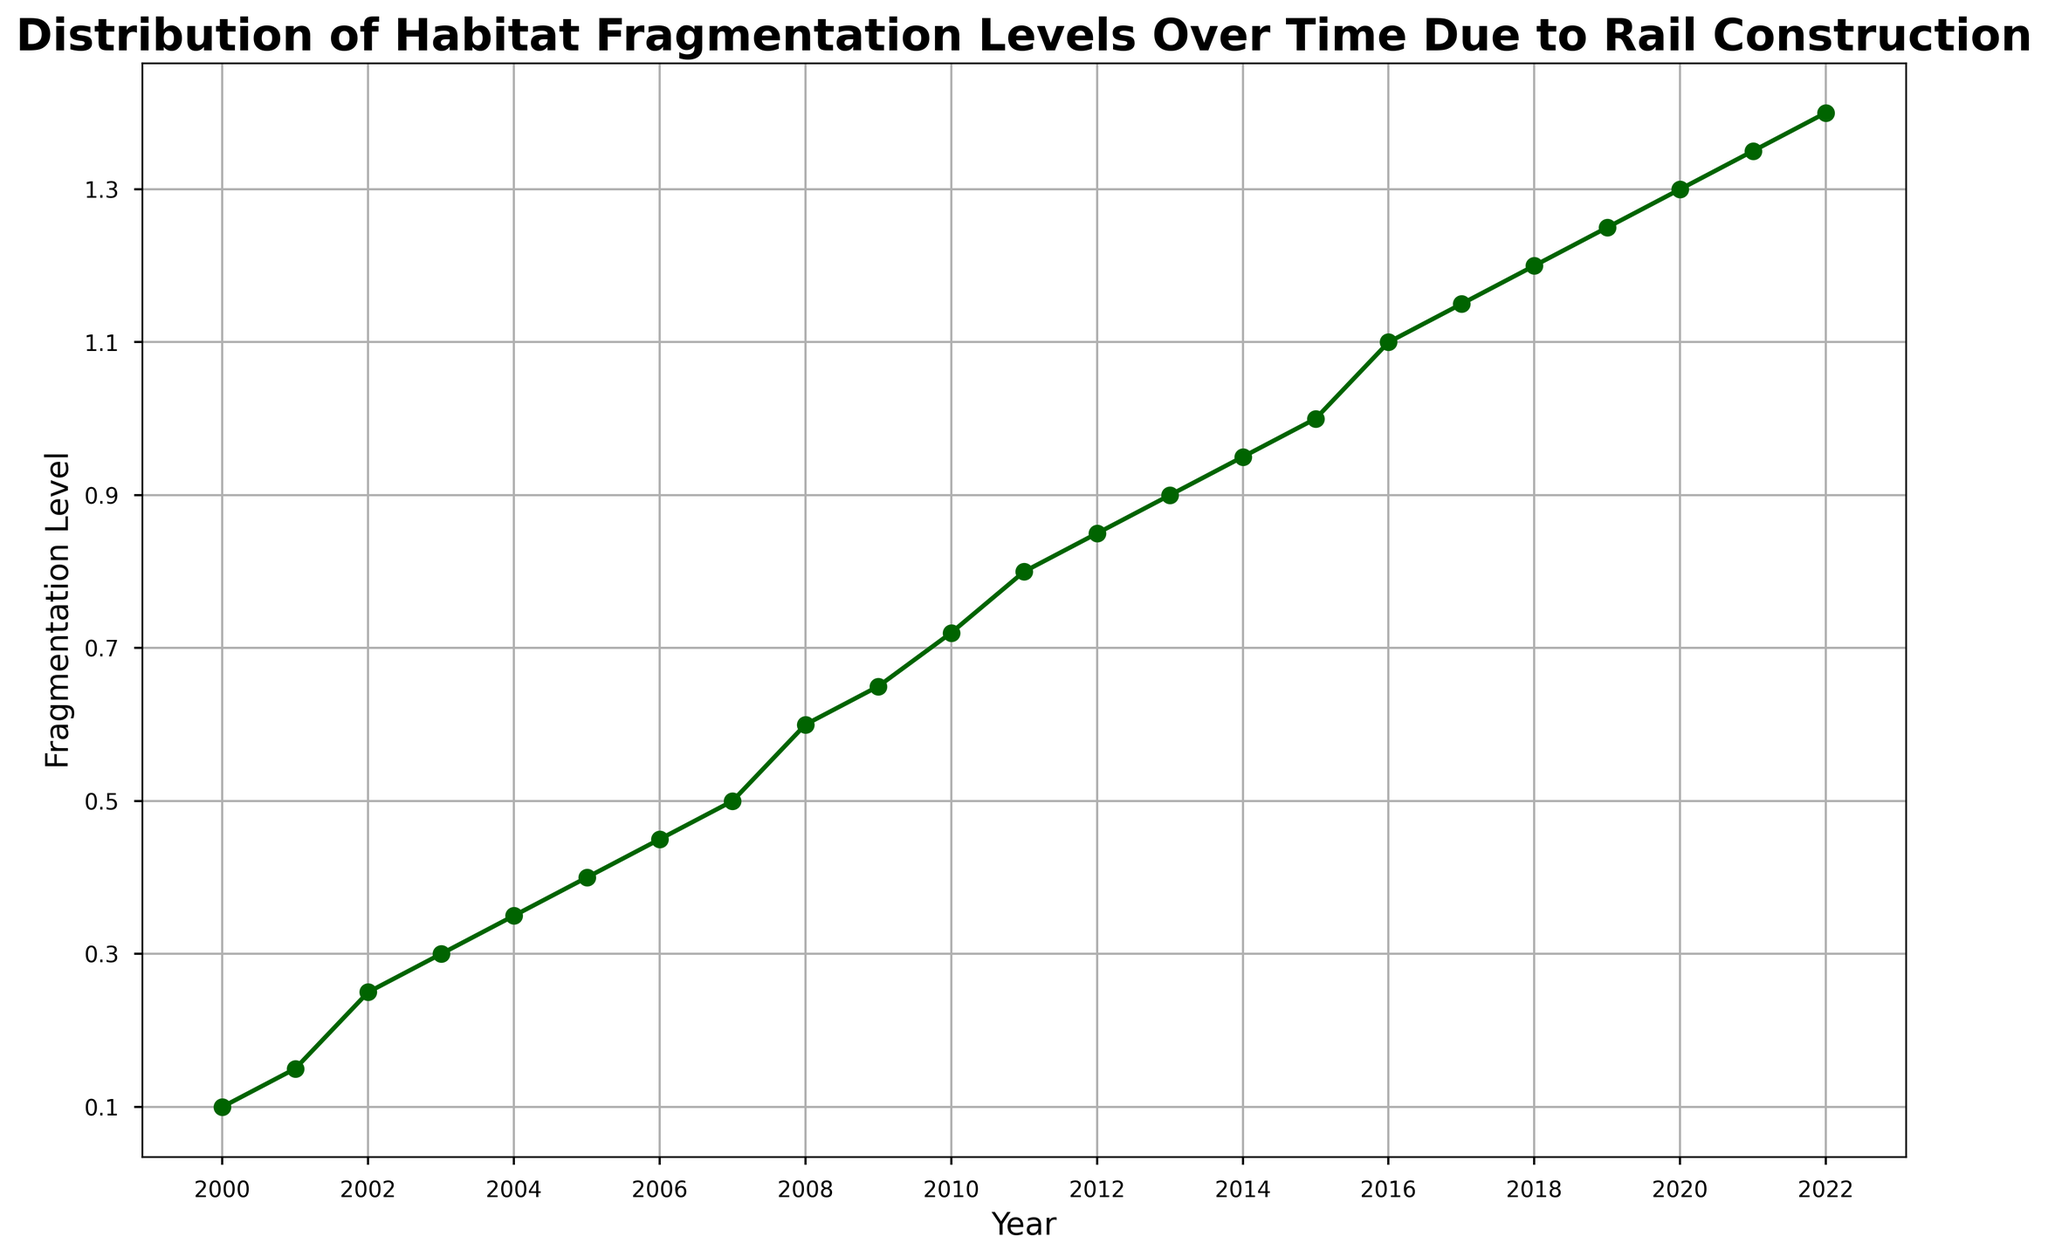What is the fragmentation level in 2005? Look at the point marked for the year 2005 on the x-axis and read the corresponding fragmentation level on the y-axis. The point is at the level 0.4.
Answer: 0.4 Between which two consecutive years did the fragmentation level increase the most? Calculate the differences between fragmentation levels for all consecutive years and identify the two years with the highest increase. The highest increase is from 2010 to 2011, from 0.72 to 0.8.
Answer: 2010 and 2011 What is the average fragmentation level from 2000 to 2005? Sum the fragmentation levels from 2000, 2001, 2002, 2003, 2004, and 2005, then divide by the number of years (6). The sum is 0.1 + 0.15 + 0.25 + 0.3 + 0.35 + 0.4, which equals 1.55. The average is 1.55 / 6.
Answer: 0.258 Which year shows a fragmentation level of 0.95? Find the year on the x-axis that corresponds to the fragmentation level of 0.95 on the y-axis. The plot shows the year is 2014.
Answer: 2014 By how much did the fragmentation level change from 2000 to 2022? Subtract the fragmentation level in 2000 from the fragmentation level in 2022. The level in 2022 is 1.4, and in 2000 it is 0.1. The change is 1.4 - 0.1.
Answer: 1.3 What is the trend observed in the fragmentation levels over the years? Observe the general direction of the plot line from left to right. The fragmentation levels steadily increase over the years.
Answer: Increasing Which year experienced the first fragmentation level above 1.0? Find the first year on the x-axis where the fragmentation level on the y-axis exceeds 1.0. The year appears to be 2016.
Answer: 2016 How many years did it take for the fragmentation level to double from its 2004 level? Determine the fragmentation level in 2004, which is 0.35, double that value to get 0.7, and find the year when the fragmentation level first reaches or exceeds 0.7. The year is 2010, so it took 6 years (2010-2004).
Answer: 6 years Is there any year where the fragmentation level remained the same as the previous year? Check the plot to see if there are any flat segments indicating no change between consecutive years. All the points are steadily increasing with no flat segments.
Answer: No 